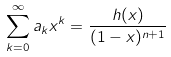Convert formula to latex. <formula><loc_0><loc_0><loc_500><loc_500>\sum _ { k = 0 } ^ { \infty } a _ { k } x ^ { k } = \frac { h ( x ) } { ( 1 - x ) ^ { n + 1 } }</formula> 